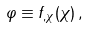<formula> <loc_0><loc_0><loc_500><loc_500>\varphi \equiv f _ { , \chi } ( \chi ) \, ,</formula> 